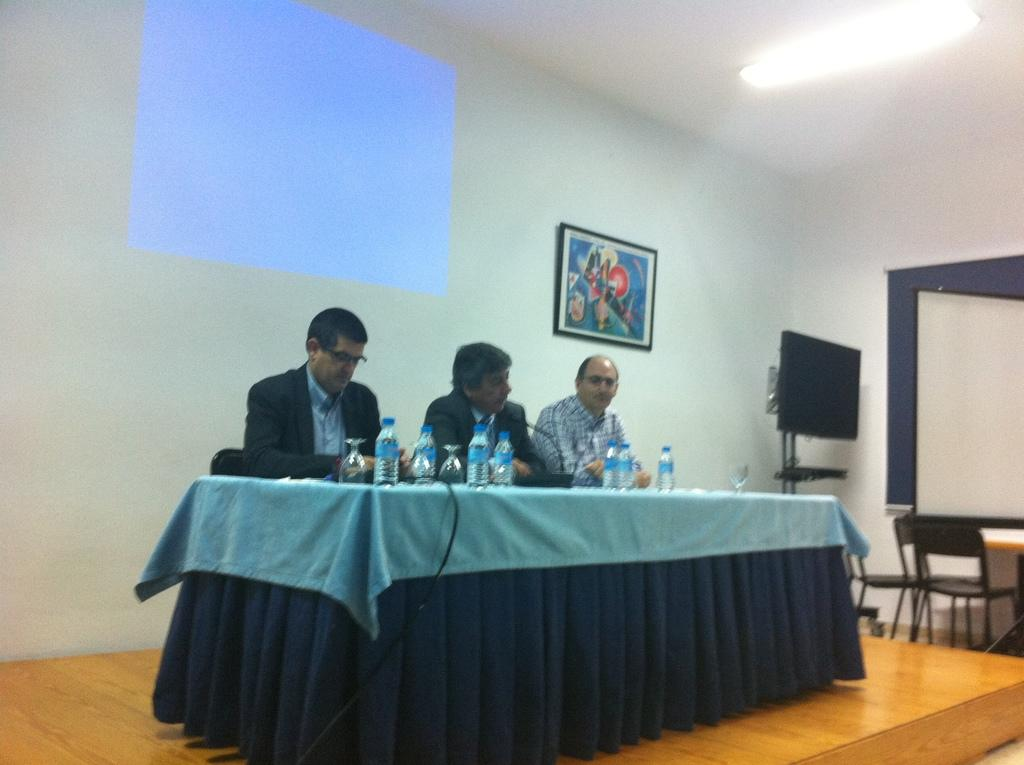Who or what is present in the image? There are people in the image. What are the people doing in the image? The people are sitting on chairs. What type of hydrant is visible in the image? There is no hydrant present in the image. 